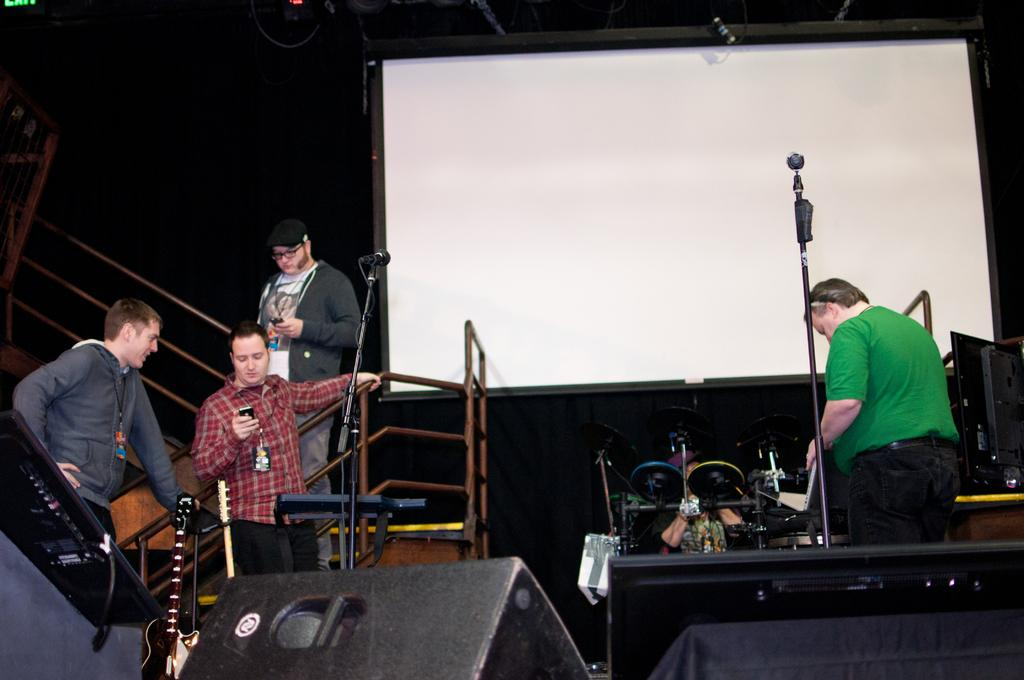What can be seen in the image involving people? There are people standing in the image. What objects are present that are typically used for amplifying sound? There are microphones (mics) in the image. What type of device is visible for displaying information or visuals? There is a screen in the image. Can you see any trees or a lake in the image? There is no mention of trees or a lake in the provided facts, so we cannot determine their presence in the image. 